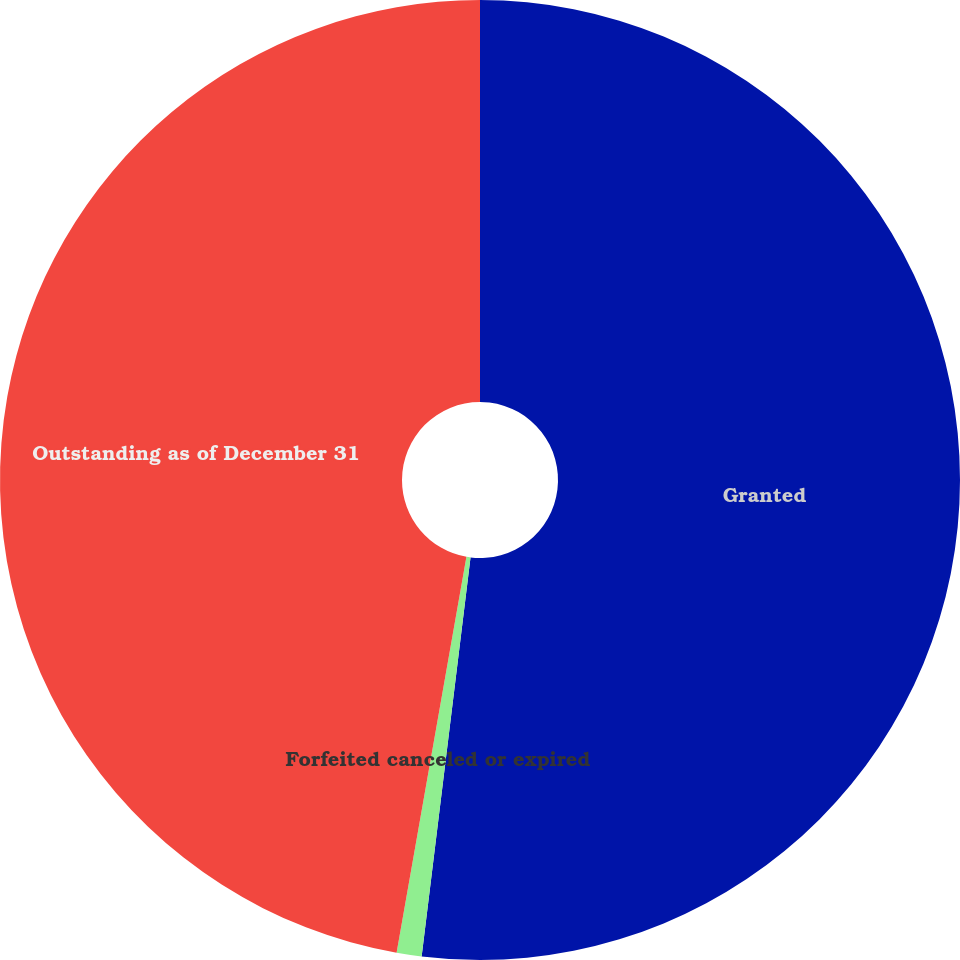Convert chart. <chart><loc_0><loc_0><loc_500><loc_500><pie_chart><fcel>Granted<fcel>Forfeited canceled or expired<fcel>Outstanding as of December 31<nl><fcel>51.94%<fcel>0.84%<fcel>47.22%<nl></chart> 